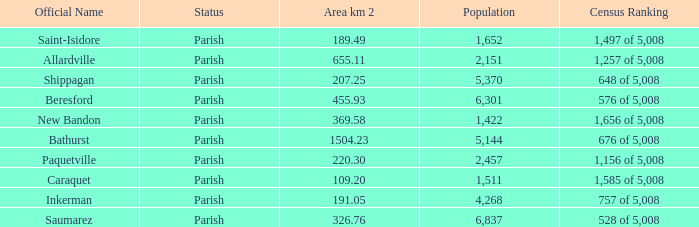Parse the full table. {'header': ['Official Name', 'Status', 'Area km 2', 'Population', 'Census Ranking'], 'rows': [['Saint-Isidore', 'Parish', '189.49', '1,652', '1,497 of 5,008'], ['Allardville', 'Parish', '655.11', '2,151', '1,257 of 5,008'], ['Shippagan', 'Parish', '207.25', '5,370', '648 of 5,008'], ['Beresford', 'Parish', '455.93', '6,301', '576 of 5,008'], ['New Bandon', 'Parish', '369.58', '1,422', '1,656 of 5,008'], ['Bathurst', 'Parish', '1504.23', '5,144', '676 of 5,008'], ['Paquetville', 'Parish', '220.30', '2,457', '1,156 of 5,008'], ['Caraquet', 'Parish', '109.20', '1,511', '1,585 of 5,008'], ['Inkerman', 'Parish', '191.05', '4,268', '757 of 5,008'], ['Saumarez', 'Parish', '326.76', '6,837', '528 of 5,008']]} What is the Area of the Saint-Isidore Parish with a Population smaller than 4,268? 189.49. 